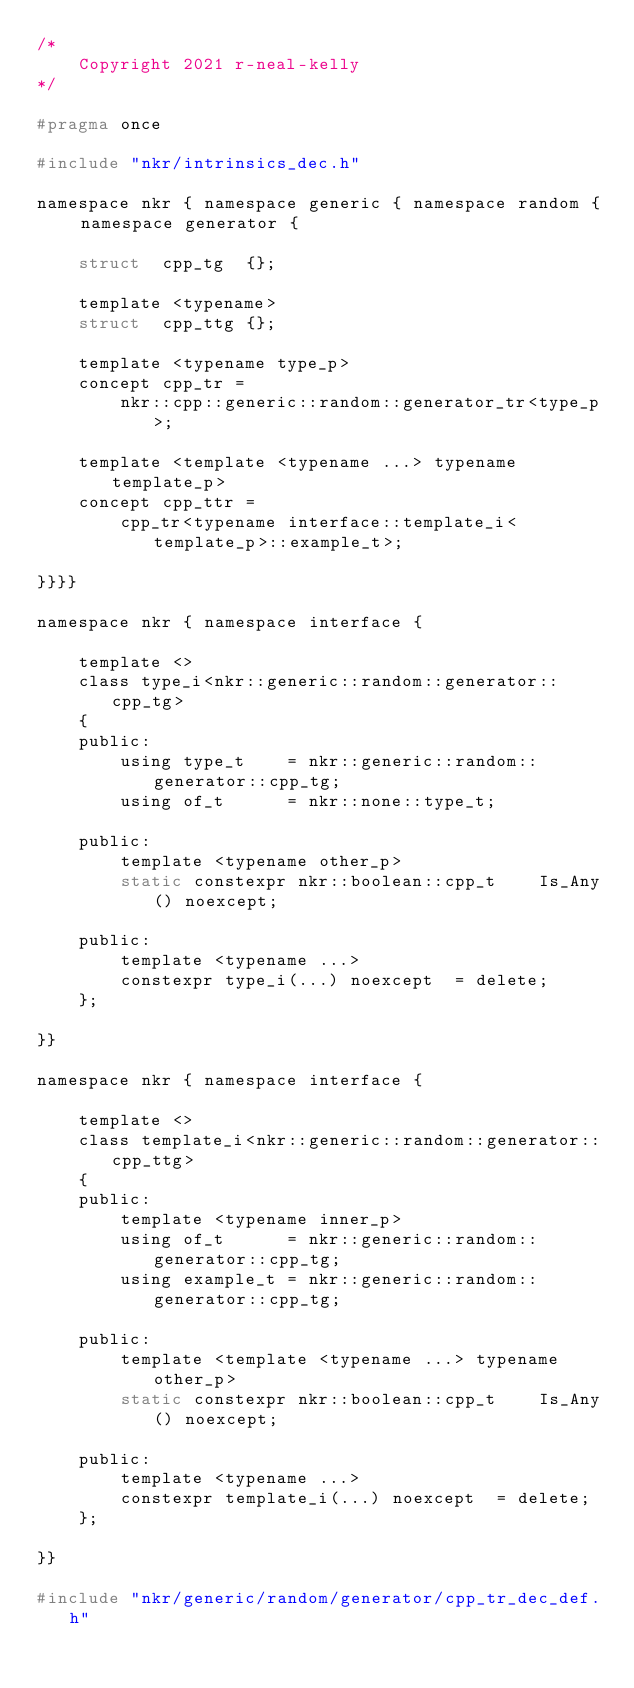<code> <loc_0><loc_0><loc_500><loc_500><_C_>/*
    Copyright 2021 r-neal-kelly
*/

#pragma once

#include "nkr/intrinsics_dec.h"

namespace nkr { namespace generic { namespace random { namespace generator {

    struct  cpp_tg  {};

    template <typename>
    struct  cpp_ttg {};

    template <typename type_p>
    concept cpp_tr =
        nkr::cpp::generic::random::generator_tr<type_p>;

    template <template <typename ...> typename template_p>
    concept cpp_ttr =
        cpp_tr<typename interface::template_i<template_p>::example_t>;

}}}}

namespace nkr { namespace interface {

    template <>
    class type_i<nkr::generic::random::generator::cpp_tg>
    {
    public:
        using type_t    = nkr::generic::random::generator::cpp_tg;
        using of_t      = nkr::none::type_t;

    public:
        template <typename other_p>
        static constexpr nkr::boolean::cpp_t    Is_Any() noexcept;

    public:
        template <typename ...>
        constexpr type_i(...) noexcept  = delete;
    };

}}

namespace nkr { namespace interface {

    template <>
    class template_i<nkr::generic::random::generator::cpp_ttg>
    {
    public:
        template <typename inner_p>
        using of_t      = nkr::generic::random::generator::cpp_tg;
        using example_t = nkr::generic::random::generator::cpp_tg;

    public:
        template <template <typename ...> typename other_p>
        static constexpr nkr::boolean::cpp_t    Is_Any() noexcept;

    public:
        template <typename ...>
        constexpr template_i(...) noexcept  = delete;
    };

}}

#include "nkr/generic/random/generator/cpp_tr_dec_def.h"
</code> 